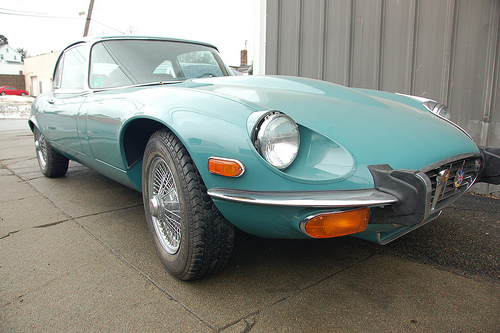<image>
Is there a car in the road? Yes. The car is contained within or inside the road, showing a containment relationship. 